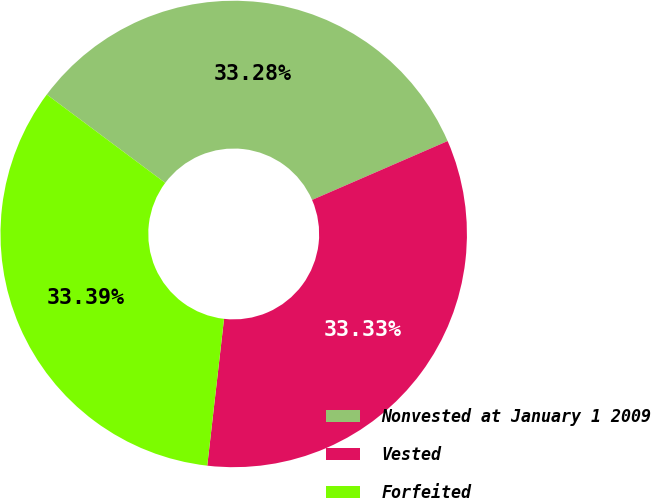<chart> <loc_0><loc_0><loc_500><loc_500><pie_chart><fcel>Nonvested at January 1 2009<fcel>Vested<fcel>Forfeited<nl><fcel>33.28%<fcel>33.33%<fcel>33.39%<nl></chart> 